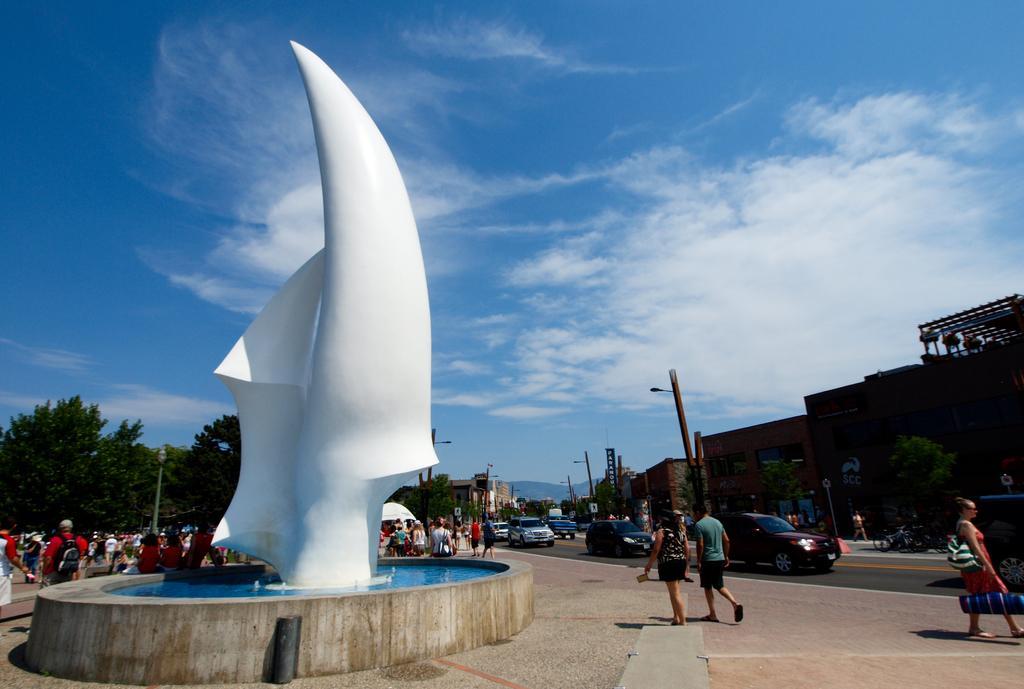Please provide a concise description of this image. In this image I can see some water, a white colored object in the water, few persons standing on the sidewalk and few persons sitting. In the background I can see the road, few vehicles on the road, few trees, few poles, few buildings, few mountains and the sky. 